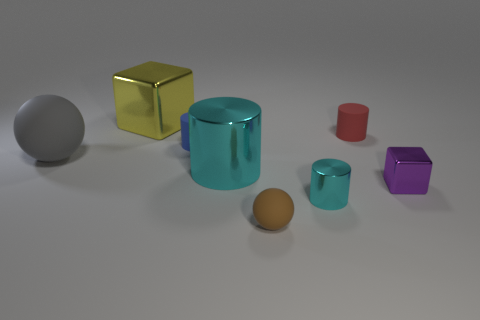What is the color of the sphere that is left of the large object that is behind the small red rubber cylinder?
Provide a short and direct response. Gray. Is the small matte sphere the same color as the large ball?
Your answer should be very brief. No. What is the material of the ball behind the cyan shiny object that is in front of the large cyan metallic thing?
Your answer should be compact. Rubber. There is a tiny purple thing that is the same shape as the large yellow metal object; what is it made of?
Your answer should be very brief. Metal. Is there a cyan shiny cylinder that is behind the tiny blue cylinder to the left of the small object behind the blue cylinder?
Offer a very short reply. No. How many other objects are there of the same color as the small rubber ball?
Offer a very short reply. 0. What number of tiny things are in front of the blue rubber object and behind the tiny brown rubber object?
Make the answer very short. 2. What shape is the large yellow thing?
Provide a succinct answer. Cube. How many other objects are there of the same material as the tiny blue cylinder?
Provide a succinct answer. 3. There is a metallic cube that is to the left of the tiny rubber thing that is in front of the shiny cylinder that is to the left of the tiny metallic cylinder; what is its color?
Your response must be concise. Yellow. 